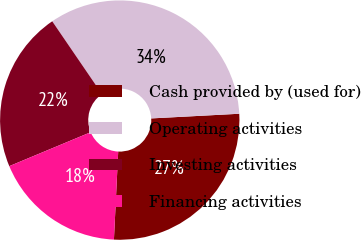Convert chart. <chart><loc_0><loc_0><loc_500><loc_500><pie_chart><fcel>Cash provided by (used for)<fcel>Operating activities<fcel>Investing activities<fcel>Financing activities<nl><fcel>26.62%<fcel>33.7%<fcel>21.75%<fcel>17.94%<nl></chart> 